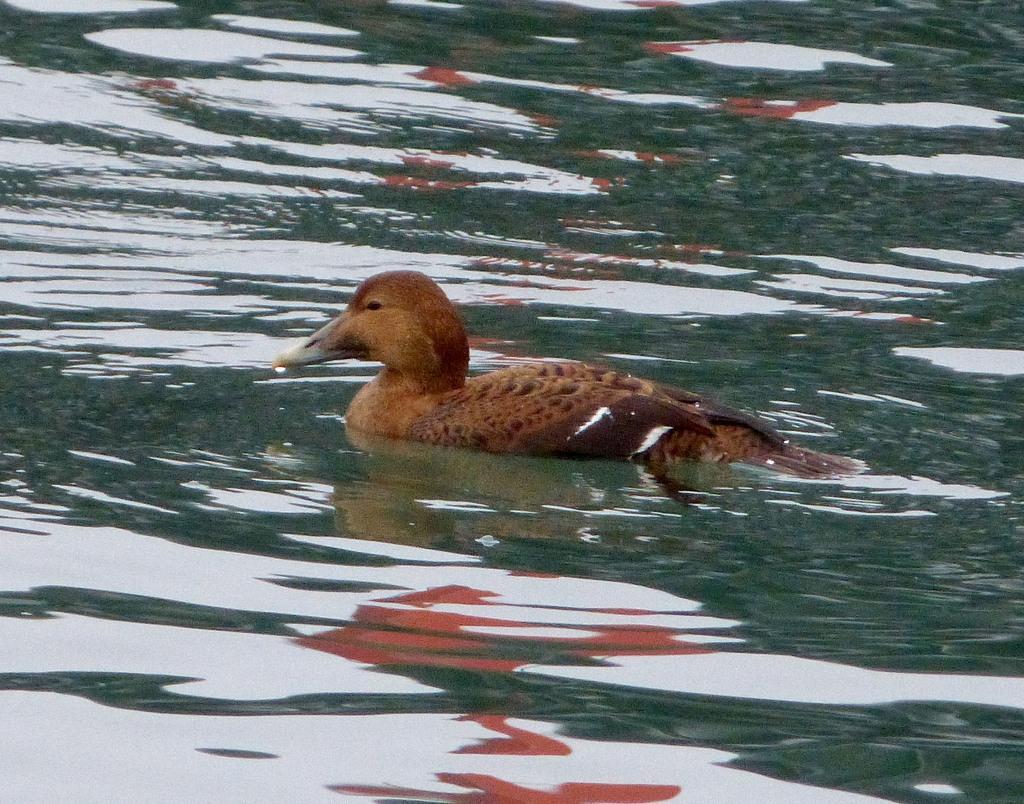Can you describe this image briefly? In the center of the image we can see one bird in the water. And we can see the bird is in brown color. In the background we can see water. 